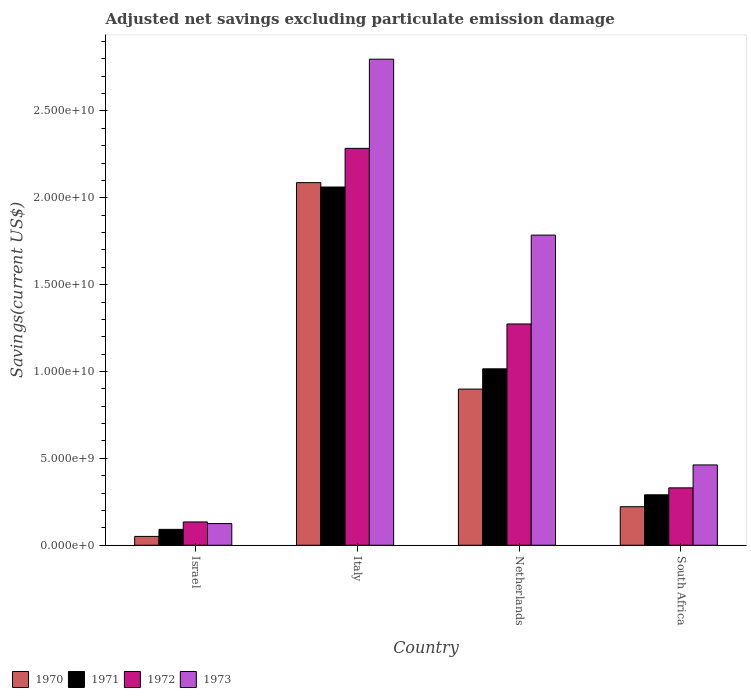What is the label of the 4th group of bars from the left?
Provide a short and direct response. South Africa. What is the adjusted net savings in 1973 in Netherlands?
Offer a very short reply. 1.79e+1. Across all countries, what is the maximum adjusted net savings in 1972?
Offer a terse response. 2.28e+1. Across all countries, what is the minimum adjusted net savings in 1971?
Offer a very short reply. 9.14e+08. In which country was the adjusted net savings in 1971 minimum?
Ensure brevity in your answer.  Israel. What is the total adjusted net savings in 1971 in the graph?
Your answer should be very brief. 3.46e+1. What is the difference between the adjusted net savings in 1972 in Netherlands and that in South Africa?
Provide a short and direct response. 9.43e+09. What is the difference between the adjusted net savings in 1972 in Netherlands and the adjusted net savings in 1971 in Israel?
Your answer should be very brief. 1.18e+1. What is the average adjusted net savings in 1970 per country?
Give a very brief answer. 8.15e+09. What is the difference between the adjusted net savings of/in 1970 and adjusted net savings of/in 1972 in Israel?
Keep it short and to the point. -8.33e+08. In how many countries, is the adjusted net savings in 1972 greater than 15000000000 US$?
Ensure brevity in your answer.  1. What is the ratio of the adjusted net savings in 1971 in Israel to that in Italy?
Your answer should be compact. 0.04. Is the adjusted net savings in 1970 in Israel less than that in Italy?
Keep it short and to the point. Yes. What is the difference between the highest and the second highest adjusted net savings in 1970?
Give a very brief answer. 1.19e+1. What is the difference between the highest and the lowest adjusted net savings in 1970?
Your answer should be very brief. 2.04e+1. In how many countries, is the adjusted net savings in 1971 greater than the average adjusted net savings in 1971 taken over all countries?
Your answer should be very brief. 2. Is the sum of the adjusted net savings in 1972 in Italy and Netherlands greater than the maximum adjusted net savings in 1970 across all countries?
Provide a succinct answer. Yes. What does the 4th bar from the left in South Africa represents?
Keep it short and to the point. 1973. Does the graph contain any zero values?
Your response must be concise. No. Where does the legend appear in the graph?
Provide a succinct answer. Bottom left. How many legend labels are there?
Provide a short and direct response. 4. How are the legend labels stacked?
Your answer should be very brief. Horizontal. What is the title of the graph?
Offer a terse response. Adjusted net savings excluding particulate emission damage. Does "2010" appear as one of the legend labels in the graph?
Ensure brevity in your answer.  No. What is the label or title of the Y-axis?
Provide a succinct answer. Savings(current US$). What is the Savings(current US$) of 1970 in Israel?
Give a very brief answer. 5.08e+08. What is the Savings(current US$) of 1971 in Israel?
Offer a terse response. 9.14e+08. What is the Savings(current US$) in 1972 in Israel?
Keep it short and to the point. 1.34e+09. What is the Savings(current US$) in 1973 in Israel?
Offer a very short reply. 1.25e+09. What is the Savings(current US$) in 1970 in Italy?
Give a very brief answer. 2.09e+1. What is the Savings(current US$) in 1971 in Italy?
Offer a very short reply. 2.06e+1. What is the Savings(current US$) in 1972 in Italy?
Ensure brevity in your answer.  2.28e+1. What is the Savings(current US$) of 1973 in Italy?
Give a very brief answer. 2.80e+1. What is the Savings(current US$) of 1970 in Netherlands?
Provide a succinct answer. 8.99e+09. What is the Savings(current US$) in 1971 in Netherlands?
Provide a short and direct response. 1.02e+1. What is the Savings(current US$) in 1972 in Netherlands?
Provide a short and direct response. 1.27e+1. What is the Savings(current US$) in 1973 in Netherlands?
Keep it short and to the point. 1.79e+1. What is the Savings(current US$) of 1970 in South Africa?
Keep it short and to the point. 2.22e+09. What is the Savings(current US$) of 1971 in South Africa?
Make the answer very short. 2.90e+09. What is the Savings(current US$) of 1972 in South Africa?
Keep it short and to the point. 3.30e+09. What is the Savings(current US$) in 1973 in South Africa?
Ensure brevity in your answer.  4.62e+09. Across all countries, what is the maximum Savings(current US$) of 1970?
Ensure brevity in your answer.  2.09e+1. Across all countries, what is the maximum Savings(current US$) in 1971?
Give a very brief answer. 2.06e+1. Across all countries, what is the maximum Savings(current US$) in 1972?
Keep it short and to the point. 2.28e+1. Across all countries, what is the maximum Savings(current US$) of 1973?
Keep it short and to the point. 2.80e+1. Across all countries, what is the minimum Savings(current US$) in 1970?
Offer a terse response. 5.08e+08. Across all countries, what is the minimum Savings(current US$) of 1971?
Your answer should be very brief. 9.14e+08. Across all countries, what is the minimum Savings(current US$) of 1972?
Provide a succinct answer. 1.34e+09. Across all countries, what is the minimum Savings(current US$) in 1973?
Ensure brevity in your answer.  1.25e+09. What is the total Savings(current US$) in 1970 in the graph?
Keep it short and to the point. 3.26e+1. What is the total Savings(current US$) in 1971 in the graph?
Your response must be concise. 3.46e+1. What is the total Savings(current US$) of 1972 in the graph?
Provide a succinct answer. 4.02e+1. What is the total Savings(current US$) of 1973 in the graph?
Make the answer very short. 5.17e+1. What is the difference between the Savings(current US$) of 1970 in Israel and that in Italy?
Your answer should be very brief. -2.04e+1. What is the difference between the Savings(current US$) of 1971 in Israel and that in Italy?
Offer a very short reply. -1.97e+1. What is the difference between the Savings(current US$) in 1972 in Israel and that in Italy?
Make the answer very short. -2.15e+1. What is the difference between the Savings(current US$) in 1973 in Israel and that in Italy?
Provide a succinct answer. -2.67e+1. What is the difference between the Savings(current US$) in 1970 in Israel and that in Netherlands?
Your response must be concise. -8.48e+09. What is the difference between the Savings(current US$) in 1971 in Israel and that in Netherlands?
Keep it short and to the point. -9.24e+09. What is the difference between the Savings(current US$) of 1972 in Israel and that in Netherlands?
Offer a terse response. -1.14e+1. What is the difference between the Savings(current US$) of 1973 in Israel and that in Netherlands?
Your answer should be compact. -1.66e+1. What is the difference between the Savings(current US$) in 1970 in Israel and that in South Africa?
Your response must be concise. -1.71e+09. What is the difference between the Savings(current US$) in 1971 in Israel and that in South Africa?
Provide a short and direct response. -1.99e+09. What is the difference between the Savings(current US$) of 1972 in Israel and that in South Africa?
Offer a terse response. -1.96e+09. What is the difference between the Savings(current US$) in 1973 in Israel and that in South Africa?
Keep it short and to the point. -3.38e+09. What is the difference between the Savings(current US$) of 1970 in Italy and that in Netherlands?
Your answer should be compact. 1.19e+1. What is the difference between the Savings(current US$) in 1971 in Italy and that in Netherlands?
Your response must be concise. 1.05e+1. What is the difference between the Savings(current US$) of 1972 in Italy and that in Netherlands?
Your answer should be compact. 1.01e+1. What is the difference between the Savings(current US$) of 1973 in Italy and that in Netherlands?
Provide a short and direct response. 1.01e+1. What is the difference between the Savings(current US$) of 1970 in Italy and that in South Africa?
Your answer should be very brief. 1.87e+1. What is the difference between the Savings(current US$) of 1971 in Italy and that in South Africa?
Keep it short and to the point. 1.77e+1. What is the difference between the Savings(current US$) in 1972 in Italy and that in South Africa?
Your answer should be compact. 1.95e+1. What is the difference between the Savings(current US$) in 1973 in Italy and that in South Africa?
Offer a terse response. 2.34e+1. What is the difference between the Savings(current US$) of 1970 in Netherlands and that in South Africa?
Your answer should be very brief. 6.77e+09. What is the difference between the Savings(current US$) in 1971 in Netherlands and that in South Africa?
Give a very brief answer. 7.25e+09. What is the difference between the Savings(current US$) in 1972 in Netherlands and that in South Africa?
Your answer should be very brief. 9.43e+09. What is the difference between the Savings(current US$) of 1973 in Netherlands and that in South Africa?
Offer a very short reply. 1.32e+1. What is the difference between the Savings(current US$) in 1970 in Israel and the Savings(current US$) in 1971 in Italy?
Provide a succinct answer. -2.01e+1. What is the difference between the Savings(current US$) in 1970 in Israel and the Savings(current US$) in 1972 in Italy?
Your answer should be compact. -2.23e+1. What is the difference between the Savings(current US$) of 1970 in Israel and the Savings(current US$) of 1973 in Italy?
Your response must be concise. -2.75e+1. What is the difference between the Savings(current US$) in 1971 in Israel and the Savings(current US$) in 1972 in Italy?
Your answer should be very brief. -2.19e+1. What is the difference between the Savings(current US$) in 1971 in Israel and the Savings(current US$) in 1973 in Italy?
Offer a very short reply. -2.71e+1. What is the difference between the Savings(current US$) of 1972 in Israel and the Savings(current US$) of 1973 in Italy?
Your answer should be compact. -2.66e+1. What is the difference between the Savings(current US$) of 1970 in Israel and the Savings(current US$) of 1971 in Netherlands?
Offer a terse response. -9.65e+09. What is the difference between the Savings(current US$) of 1970 in Israel and the Savings(current US$) of 1972 in Netherlands?
Give a very brief answer. -1.22e+1. What is the difference between the Savings(current US$) in 1970 in Israel and the Savings(current US$) in 1973 in Netherlands?
Your answer should be compact. -1.73e+1. What is the difference between the Savings(current US$) in 1971 in Israel and the Savings(current US$) in 1972 in Netherlands?
Your response must be concise. -1.18e+1. What is the difference between the Savings(current US$) of 1971 in Israel and the Savings(current US$) of 1973 in Netherlands?
Provide a succinct answer. -1.69e+1. What is the difference between the Savings(current US$) of 1972 in Israel and the Savings(current US$) of 1973 in Netherlands?
Keep it short and to the point. -1.65e+1. What is the difference between the Savings(current US$) of 1970 in Israel and the Savings(current US$) of 1971 in South Africa?
Your response must be concise. -2.39e+09. What is the difference between the Savings(current US$) of 1970 in Israel and the Savings(current US$) of 1972 in South Africa?
Your answer should be compact. -2.79e+09. What is the difference between the Savings(current US$) in 1970 in Israel and the Savings(current US$) in 1973 in South Africa?
Your response must be concise. -4.11e+09. What is the difference between the Savings(current US$) of 1971 in Israel and the Savings(current US$) of 1972 in South Africa?
Provide a succinct answer. -2.39e+09. What is the difference between the Savings(current US$) of 1971 in Israel and the Savings(current US$) of 1973 in South Africa?
Your answer should be compact. -3.71e+09. What is the difference between the Savings(current US$) in 1972 in Israel and the Savings(current US$) in 1973 in South Africa?
Ensure brevity in your answer.  -3.28e+09. What is the difference between the Savings(current US$) in 1970 in Italy and the Savings(current US$) in 1971 in Netherlands?
Offer a very short reply. 1.07e+1. What is the difference between the Savings(current US$) of 1970 in Italy and the Savings(current US$) of 1972 in Netherlands?
Offer a very short reply. 8.14e+09. What is the difference between the Savings(current US$) in 1970 in Italy and the Savings(current US$) in 1973 in Netherlands?
Offer a very short reply. 3.02e+09. What is the difference between the Savings(current US$) of 1971 in Italy and the Savings(current US$) of 1972 in Netherlands?
Offer a terse response. 7.88e+09. What is the difference between the Savings(current US$) in 1971 in Italy and the Savings(current US$) in 1973 in Netherlands?
Make the answer very short. 2.77e+09. What is the difference between the Savings(current US$) in 1972 in Italy and the Savings(current US$) in 1973 in Netherlands?
Keep it short and to the point. 4.99e+09. What is the difference between the Savings(current US$) in 1970 in Italy and the Savings(current US$) in 1971 in South Africa?
Keep it short and to the point. 1.80e+1. What is the difference between the Savings(current US$) in 1970 in Italy and the Savings(current US$) in 1972 in South Africa?
Provide a short and direct response. 1.76e+1. What is the difference between the Savings(current US$) in 1970 in Italy and the Savings(current US$) in 1973 in South Africa?
Provide a short and direct response. 1.62e+1. What is the difference between the Savings(current US$) of 1971 in Italy and the Savings(current US$) of 1972 in South Africa?
Your answer should be very brief. 1.73e+1. What is the difference between the Savings(current US$) of 1971 in Italy and the Savings(current US$) of 1973 in South Africa?
Offer a very short reply. 1.60e+1. What is the difference between the Savings(current US$) in 1972 in Italy and the Savings(current US$) in 1973 in South Africa?
Provide a short and direct response. 1.82e+1. What is the difference between the Savings(current US$) in 1970 in Netherlands and the Savings(current US$) in 1971 in South Africa?
Keep it short and to the point. 6.09e+09. What is the difference between the Savings(current US$) of 1970 in Netherlands and the Savings(current US$) of 1972 in South Africa?
Provide a short and direct response. 5.69e+09. What is the difference between the Savings(current US$) of 1970 in Netherlands and the Savings(current US$) of 1973 in South Africa?
Offer a very short reply. 4.37e+09. What is the difference between the Savings(current US$) of 1971 in Netherlands and the Savings(current US$) of 1972 in South Africa?
Provide a succinct answer. 6.85e+09. What is the difference between the Savings(current US$) of 1971 in Netherlands and the Savings(current US$) of 1973 in South Africa?
Give a very brief answer. 5.53e+09. What is the difference between the Savings(current US$) of 1972 in Netherlands and the Savings(current US$) of 1973 in South Africa?
Offer a terse response. 8.11e+09. What is the average Savings(current US$) in 1970 per country?
Give a very brief answer. 8.15e+09. What is the average Savings(current US$) of 1971 per country?
Your answer should be compact. 8.65e+09. What is the average Savings(current US$) of 1972 per country?
Keep it short and to the point. 1.01e+1. What is the average Savings(current US$) in 1973 per country?
Make the answer very short. 1.29e+1. What is the difference between the Savings(current US$) in 1970 and Savings(current US$) in 1971 in Israel?
Ensure brevity in your answer.  -4.06e+08. What is the difference between the Savings(current US$) of 1970 and Savings(current US$) of 1972 in Israel?
Provide a short and direct response. -8.33e+08. What is the difference between the Savings(current US$) of 1970 and Savings(current US$) of 1973 in Israel?
Keep it short and to the point. -7.39e+08. What is the difference between the Savings(current US$) of 1971 and Savings(current US$) of 1972 in Israel?
Make the answer very short. -4.27e+08. What is the difference between the Savings(current US$) in 1971 and Savings(current US$) in 1973 in Israel?
Keep it short and to the point. -3.33e+08. What is the difference between the Savings(current US$) in 1972 and Savings(current US$) in 1973 in Israel?
Provide a short and direct response. 9.40e+07. What is the difference between the Savings(current US$) in 1970 and Savings(current US$) in 1971 in Italy?
Your response must be concise. 2.53e+08. What is the difference between the Savings(current US$) of 1970 and Savings(current US$) of 1972 in Italy?
Offer a very short reply. -1.97e+09. What is the difference between the Savings(current US$) of 1970 and Savings(current US$) of 1973 in Italy?
Make the answer very short. -7.11e+09. What is the difference between the Savings(current US$) of 1971 and Savings(current US$) of 1972 in Italy?
Your response must be concise. -2.23e+09. What is the difference between the Savings(current US$) of 1971 and Savings(current US$) of 1973 in Italy?
Offer a terse response. -7.36e+09. What is the difference between the Savings(current US$) in 1972 and Savings(current US$) in 1973 in Italy?
Give a very brief answer. -5.13e+09. What is the difference between the Savings(current US$) of 1970 and Savings(current US$) of 1971 in Netherlands?
Your response must be concise. -1.17e+09. What is the difference between the Savings(current US$) in 1970 and Savings(current US$) in 1972 in Netherlands?
Your answer should be very brief. -3.75e+09. What is the difference between the Savings(current US$) in 1970 and Savings(current US$) in 1973 in Netherlands?
Your answer should be compact. -8.86e+09. What is the difference between the Savings(current US$) of 1971 and Savings(current US$) of 1972 in Netherlands?
Your answer should be very brief. -2.58e+09. What is the difference between the Savings(current US$) of 1971 and Savings(current US$) of 1973 in Netherlands?
Your answer should be very brief. -7.70e+09. What is the difference between the Savings(current US$) of 1972 and Savings(current US$) of 1973 in Netherlands?
Your answer should be very brief. -5.11e+09. What is the difference between the Savings(current US$) of 1970 and Savings(current US$) of 1971 in South Africa?
Make the answer very short. -6.85e+08. What is the difference between the Savings(current US$) in 1970 and Savings(current US$) in 1972 in South Africa?
Make the answer very short. -1.08e+09. What is the difference between the Savings(current US$) in 1970 and Savings(current US$) in 1973 in South Africa?
Make the answer very short. -2.40e+09. What is the difference between the Savings(current US$) in 1971 and Savings(current US$) in 1972 in South Africa?
Provide a succinct answer. -4.00e+08. What is the difference between the Savings(current US$) of 1971 and Savings(current US$) of 1973 in South Africa?
Provide a succinct answer. -1.72e+09. What is the difference between the Savings(current US$) in 1972 and Savings(current US$) in 1973 in South Africa?
Provide a succinct answer. -1.32e+09. What is the ratio of the Savings(current US$) in 1970 in Israel to that in Italy?
Your response must be concise. 0.02. What is the ratio of the Savings(current US$) of 1971 in Israel to that in Italy?
Your answer should be very brief. 0.04. What is the ratio of the Savings(current US$) in 1972 in Israel to that in Italy?
Your answer should be very brief. 0.06. What is the ratio of the Savings(current US$) of 1973 in Israel to that in Italy?
Keep it short and to the point. 0.04. What is the ratio of the Savings(current US$) in 1970 in Israel to that in Netherlands?
Provide a succinct answer. 0.06. What is the ratio of the Savings(current US$) in 1971 in Israel to that in Netherlands?
Your answer should be very brief. 0.09. What is the ratio of the Savings(current US$) of 1972 in Israel to that in Netherlands?
Ensure brevity in your answer.  0.11. What is the ratio of the Savings(current US$) of 1973 in Israel to that in Netherlands?
Your response must be concise. 0.07. What is the ratio of the Savings(current US$) of 1970 in Israel to that in South Africa?
Give a very brief answer. 0.23. What is the ratio of the Savings(current US$) of 1971 in Israel to that in South Africa?
Offer a terse response. 0.32. What is the ratio of the Savings(current US$) in 1972 in Israel to that in South Africa?
Offer a terse response. 0.41. What is the ratio of the Savings(current US$) in 1973 in Israel to that in South Africa?
Ensure brevity in your answer.  0.27. What is the ratio of the Savings(current US$) in 1970 in Italy to that in Netherlands?
Your answer should be very brief. 2.32. What is the ratio of the Savings(current US$) in 1971 in Italy to that in Netherlands?
Provide a succinct answer. 2.03. What is the ratio of the Savings(current US$) of 1972 in Italy to that in Netherlands?
Provide a succinct answer. 1.79. What is the ratio of the Savings(current US$) in 1973 in Italy to that in Netherlands?
Your response must be concise. 1.57. What is the ratio of the Savings(current US$) of 1970 in Italy to that in South Africa?
Ensure brevity in your answer.  9.41. What is the ratio of the Savings(current US$) in 1971 in Italy to that in South Africa?
Give a very brief answer. 7.1. What is the ratio of the Savings(current US$) of 1972 in Italy to that in South Africa?
Provide a succinct answer. 6.92. What is the ratio of the Savings(current US$) of 1973 in Italy to that in South Africa?
Your answer should be very brief. 6.05. What is the ratio of the Savings(current US$) of 1970 in Netherlands to that in South Africa?
Ensure brevity in your answer.  4.05. What is the ratio of the Savings(current US$) in 1971 in Netherlands to that in South Africa?
Offer a terse response. 3.5. What is the ratio of the Savings(current US$) of 1972 in Netherlands to that in South Africa?
Your answer should be compact. 3.86. What is the ratio of the Savings(current US$) of 1973 in Netherlands to that in South Africa?
Provide a short and direct response. 3.86. What is the difference between the highest and the second highest Savings(current US$) of 1970?
Offer a terse response. 1.19e+1. What is the difference between the highest and the second highest Savings(current US$) of 1971?
Keep it short and to the point. 1.05e+1. What is the difference between the highest and the second highest Savings(current US$) in 1972?
Offer a terse response. 1.01e+1. What is the difference between the highest and the second highest Savings(current US$) of 1973?
Your answer should be compact. 1.01e+1. What is the difference between the highest and the lowest Savings(current US$) in 1970?
Ensure brevity in your answer.  2.04e+1. What is the difference between the highest and the lowest Savings(current US$) of 1971?
Make the answer very short. 1.97e+1. What is the difference between the highest and the lowest Savings(current US$) of 1972?
Your response must be concise. 2.15e+1. What is the difference between the highest and the lowest Savings(current US$) in 1973?
Your response must be concise. 2.67e+1. 